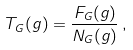<formula> <loc_0><loc_0><loc_500><loc_500>T _ { G } ( g ) = \frac { F _ { G } ( g ) } { N _ { G } ( g ) } \, ,</formula> 